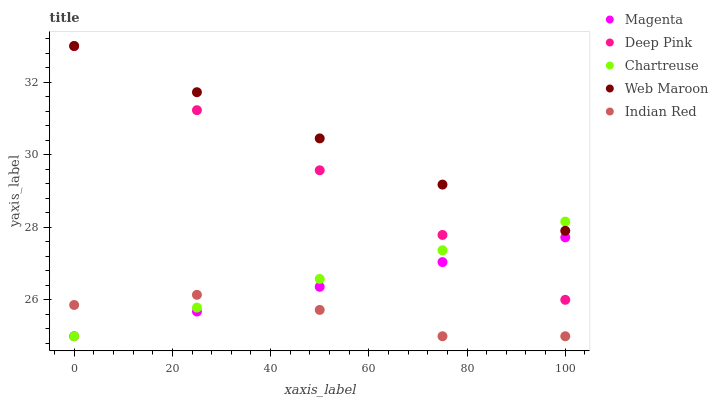Does Indian Red have the minimum area under the curve?
Answer yes or no. Yes. Does Web Maroon have the maximum area under the curve?
Answer yes or no. Yes. Does Deep Pink have the minimum area under the curve?
Answer yes or no. No. Does Deep Pink have the maximum area under the curve?
Answer yes or no. No. Is Web Maroon the smoothest?
Answer yes or no. Yes. Is Indian Red the roughest?
Answer yes or no. Yes. Is Deep Pink the smoothest?
Answer yes or no. No. Is Deep Pink the roughest?
Answer yes or no. No. Does Magenta have the lowest value?
Answer yes or no. Yes. Does Deep Pink have the lowest value?
Answer yes or no. No. Does Web Maroon have the highest value?
Answer yes or no. Yes. Does Chartreuse have the highest value?
Answer yes or no. No. Is Indian Red less than Deep Pink?
Answer yes or no. Yes. Is Web Maroon greater than Indian Red?
Answer yes or no. Yes. Does Deep Pink intersect Web Maroon?
Answer yes or no. Yes. Is Deep Pink less than Web Maroon?
Answer yes or no. No. Is Deep Pink greater than Web Maroon?
Answer yes or no. No. Does Indian Red intersect Deep Pink?
Answer yes or no. No. 